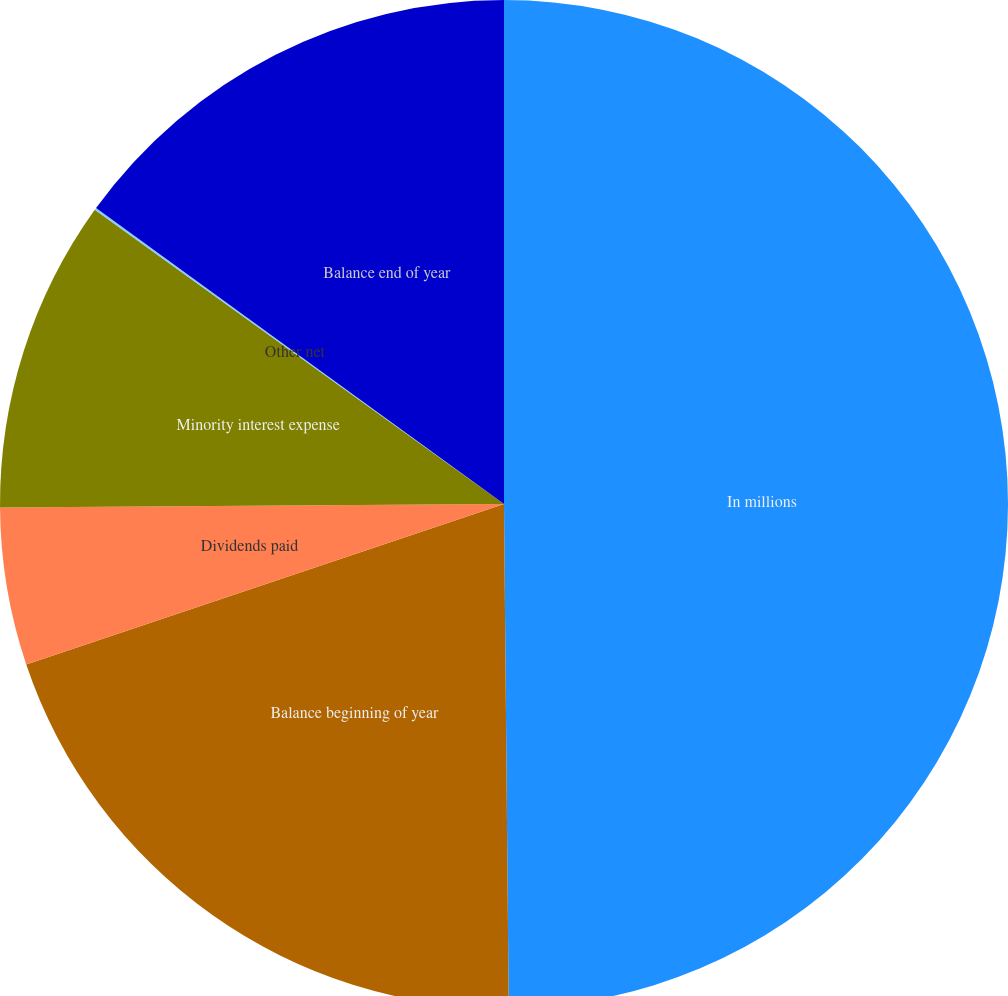<chart> <loc_0><loc_0><loc_500><loc_500><pie_chart><fcel>In millions<fcel>Balance beginning of year<fcel>Dividends paid<fcel>Minority interest expense<fcel>Other net<fcel>Balance end of year<nl><fcel>49.85%<fcel>19.99%<fcel>5.05%<fcel>10.03%<fcel>0.07%<fcel>15.01%<nl></chart> 